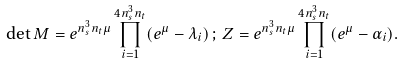<formula> <loc_0><loc_0><loc_500><loc_500>\det M = e ^ { n _ { s } ^ { 3 } n _ { t } \mu } \prod _ { i = 1 } ^ { 4 n _ { s } ^ { 3 } n _ { t } } ( e ^ { \mu } - \lambda _ { i } ) \, ; \, Z = e ^ { n _ { s } ^ { 3 } n _ { t } \mu } \prod _ { i = 1 } ^ { 4 n _ { s } ^ { 3 } n _ { t } } ( e ^ { \mu } - \alpha _ { i } ) .</formula> 